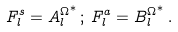Convert formula to latex. <formula><loc_0><loc_0><loc_500><loc_500>F ^ { s } _ { l } = { A ^ { \Omega } _ { l } } ^ { * } \, ; \, F ^ { a } _ { l } = { B ^ { \Omega } _ { l } } ^ { * } \, .</formula> 